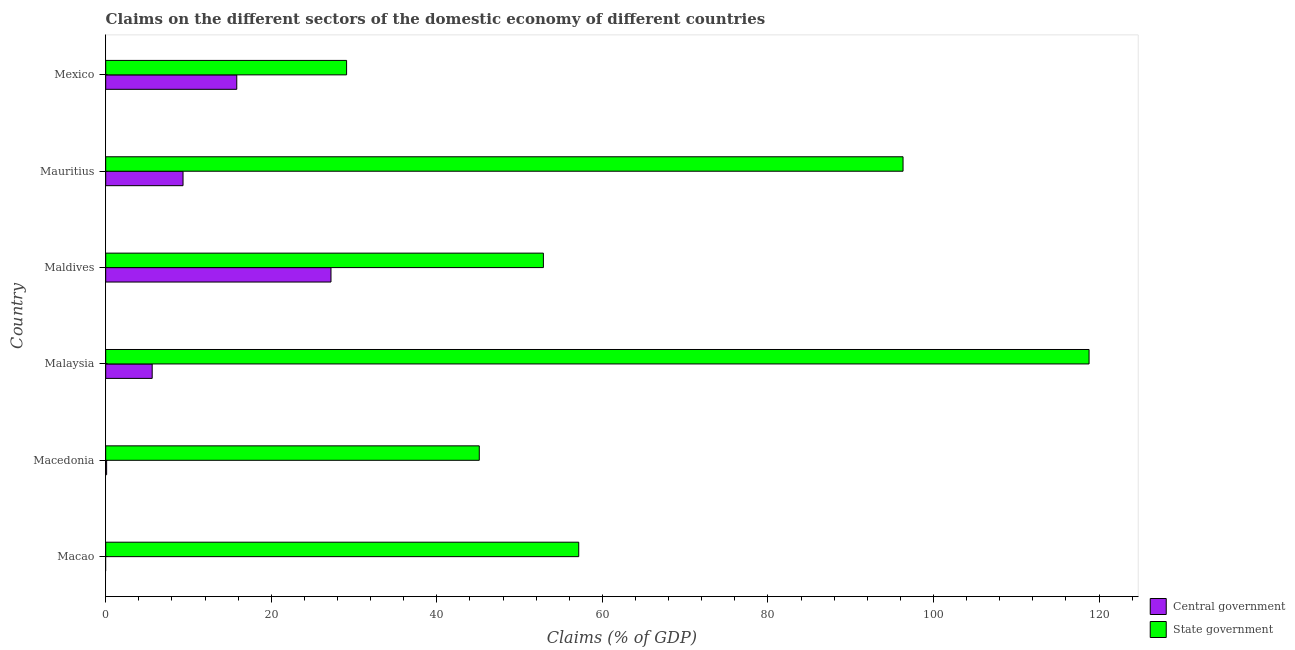How many different coloured bars are there?
Provide a succinct answer. 2. How many bars are there on the 3rd tick from the top?
Give a very brief answer. 2. In how many cases, is the number of bars for a given country not equal to the number of legend labels?
Offer a terse response. 1. What is the claims on state government in Mauritius?
Your response must be concise. 96.32. Across all countries, what is the maximum claims on central government?
Make the answer very short. 27.22. Across all countries, what is the minimum claims on state government?
Provide a succinct answer. 29.1. In which country was the claims on state government maximum?
Your response must be concise. Malaysia. What is the total claims on central government in the graph?
Your answer should be compact. 58.12. What is the difference between the claims on central government in Mauritius and that in Mexico?
Offer a very short reply. -6.49. What is the difference between the claims on central government in Mauritius and the claims on state government in Macedonia?
Your response must be concise. -35.79. What is the average claims on state government per country?
Offer a very short reply. 66.56. What is the difference between the claims on state government and claims on central government in Mauritius?
Keep it short and to the point. 86.98. In how many countries, is the claims on state government greater than 92 %?
Provide a succinct answer. 2. What is the ratio of the claims on state government in Macao to that in Mexico?
Your answer should be compact. 1.96. What is the difference between the highest and the second highest claims on state government?
Provide a short and direct response. 22.47. What is the difference between the highest and the lowest claims on state government?
Your answer should be compact. 89.69. Is the sum of the claims on state government in Macedonia and Mexico greater than the maximum claims on central government across all countries?
Your answer should be very brief. Yes. How many bars are there?
Keep it short and to the point. 11. How many countries are there in the graph?
Offer a very short reply. 6. What is the difference between two consecutive major ticks on the X-axis?
Your response must be concise. 20. Does the graph contain any zero values?
Give a very brief answer. Yes. Does the graph contain grids?
Offer a terse response. No. How many legend labels are there?
Offer a very short reply. 2. How are the legend labels stacked?
Your answer should be compact. Vertical. What is the title of the graph?
Offer a terse response. Claims on the different sectors of the domestic economy of different countries. What is the label or title of the X-axis?
Provide a short and direct response. Claims (% of GDP). What is the label or title of the Y-axis?
Provide a succinct answer. Country. What is the Claims (% of GDP) in State government in Macao?
Keep it short and to the point. 57.14. What is the Claims (% of GDP) in Central government in Macedonia?
Your response must be concise. 0.11. What is the Claims (% of GDP) of State government in Macedonia?
Offer a terse response. 45.13. What is the Claims (% of GDP) in Central government in Malaysia?
Keep it short and to the point. 5.62. What is the Claims (% of GDP) of State government in Malaysia?
Offer a terse response. 118.79. What is the Claims (% of GDP) in Central government in Maldives?
Provide a succinct answer. 27.22. What is the Claims (% of GDP) of State government in Maldives?
Offer a terse response. 52.87. What is the Claims (% of GDP) in Central government in Mauritius?
Your response must be concise. 9.34. What is the Claims (% of GDP) of State government in Mauritius?
Your answer should be very brief. 96.32. What is the Claims (% of GDP) of Central government in Mexico?
Give a very brief answer. 15.83. What is the Claims (% of GDP) of State government in Mexico?
Provide a succinct answer. 29.1. Across all countries, what is the maximum Claims (% of GDP) of Central government?
Make the answer very short. 27.22. Across all countries, what is the maximum Claims (% of GDP) in State government?
Offer a terse response. 118.79. Across all countries, what is the minimum Claims (% of GDP) of Central government?
Offer a very short reply. 0. Across all countries, what is the minimum Claims (% of GDP) in State government?
Make the answer very short. 29.1. What is the total Claims (% of GDP) of Central government in the graph?
Ensure brevity in your answer.  58.12. What is the total Claims (% of GDP) in State government in the graph?
Ensure brevity in your answer.  399.36. What is the difference between the Claims (% of GDP) in State government in Macao and that in Macedonia?
Your response must be concise. 12.01. What is the difference between the Claims (% of GDP) in State government in Macao and that in Malaysia?
Make the answer very short. -61.65. What is the difference between the Claims (% of GDP) in State government in Macao and that in Maldives?
Keep it short and to the point. 4.27. What is the difference between the Claims (% of GDP) in State government in Macao and that in Mauritius?
Your response must be concise. -39.18. What is the difference between the Claims (% of GDP) of State government in Macao and that in Mexico?
Your answer should be compact. 28.04. What is the difference between the Claims (% of GDP) in Central government in Macedonia and that in Malaysia?
Give a very brief answer. -5.5. What is the difference between the Claims (% of GDP) in State government in Macedonia and that in Malaysia?
Make the answer very short. -73.66. What is the difference between the Claims (% of GDP) of Central government in Macedonia and that in Maldives?
Ensure brevity in your answer.  -27.1. What is the difference between the Claims (% of GDP) of State government in Macedonia and that in Maldives?
Keep it short and to the point. -7.74. What is the difference between the Claims (% of GDP) of Central government in Macedonia and that in Mauritius?
Your answer should be compact. -9.23. What is the difference between the Claims (% of GDP) in State government in Macedonia and that in Mauritius?
Your answer should be very brief. -51.19. What is the difference between the Claims (% of GDP) of Central government in Macedonia and that in Mexico?
Your answer should be very brief. -15.72. What is the difference between the Claims (% of GDP) in State government in Macedonia and that in Mexico?
Ensure brevity in your answer.  16.03. What is the difference between the Claims (% of GDP) in Central government in Malaysia and that in Maldives?
Keep it short and to the point. -21.6. What is the difference between the Claims (% of GDP) in State government in Malaysia and that in Maldives?
Your answer should be very brief. 65.92. What is the difference between the Claims (% of GDP) of Central government in Malaysia and that in Mauritius?
Your response must be concise. -3.72. What is the difference between the Claims (% of GDP) of State government in Malaysia and that in Mauritius?
Give a very brief answer. 22.47. What is the difference between the Claims (% of GDP) of Central government in Malaysia and that in Mexico?
Provide a succinct answer. -10.22. What is the difference between the Claims (% of GDP) of State government in Malaysia and that in Mexico?
Ensure brevity in your answer.  89.69. What is the difference between the Claims (% of GDP) of Central government in Maldives and that in Mauritius?
Your answer should be compact. 17.87. What is the difference between the Claims (% of GDP) of State government in Maldives and that in Mauritius?
Your answer should be compact. -43.45. What is the difference between the Claims (% of GDP) in Central government in Maldives and that in Mexico?
Keep it short and to the point. 11.38. What is the difference between the Claims (% of GDP) in State government in Maldives and that in Mexico?
Make the answer very short. 23.77. What is the difference between the Claims (% of GDP) of Central government in Mauritius and that in Mexico?
Provide a succinct answer. -6.49. What is the difference between the Claims (% of GDP) in State government in Mauritius and that in Mexico?
Offer a very short reply. 67.22. What is the difference between the Claims (% of GDP) in Central government in Macedonia and the Claims (% of GDP) in State government in Malaysia?
Your answer should be very brief. -118.68. What is the difference between the Claims (% of GDP) of Central government in Macedonia and the Claims (% of GDP) of State government in Maldives?
Give a very brief answer. -52.76. What is the difference between the Claims (% of GDP) of Central government in Macedonia and the Claims (% of GDP) of State government in Mauritius?
Your response must be concise. -96.21. What is the difference between the Claims (% of GDP) of Central government in Macedonia and the Claims (% of GDP) of State government in Mexico?
Give a very brief answer. -28.99. What is the difference between the Claims (% of GDP) in Central government in Malaysia and the Claims (% of GDP) in State government in Maldives?
Your answer should be compact. -47.26. What is the difference between the Claims (% of GDP) in Central government in Malaysia and the Claims (% of GDP) in State government in Mauritius?
Offer a very short reply. -90.7. What is the difference between the Claims (% of GDP) in Central government in Malaysia and the Claims (% of GDP) in State government in Mexico?
Give a very brief answer. -23.48. What is the difference between the Claims (% of GDP) of Central government in Maldives and the Claims (% of GDP) of State government in Mauritius?
Ensure brevity in your answer.  -69.11. What is the difference between the Claims (% of GDP) of Central government in Maldives and the Claims (% of GDP) of State government in Mexico?
Keep it short and to the point. -1.89. What is the difference between the Claims (% of GDP) in Central government in Mauritius and the Claims (% of GDP) in State government in Mexico?
Keep it short and to the point. -19.76. What is the average Claims (% of GDP) in Central government per country?
Offer a very short reply. 9.69. What is the average Claims (% of GDP) in State government per country?
Provide a succinct answer. 66.56. What is the difference between the Claims (% of GDP) in Central government and Claims (% of GDP) in State government in Macedonia?
Your response must be concise. -45.02. What is the difference between the Claims (% of GDP) of Central government and Claims (% of GDP) of State government in Malaysia?
Your answer should be compact. -113.18. What is the difference between the Claims (% of GDP) of Central government and Claims (% of GDP) of State government in Maldives?
Provide a short and direct response. -25.66. What is the difference between the Claims (% of GDP) in Central government and Claims (% of GDP) in State government in Mauritius?
Provide a succinct answer. -86.98. What is the difference between the Claims (% of GDP) in Central government and Claims (% of GDP) in State government in Mexico?
Provide a short and direct response. -13.27. What is the ratio of the Claims (% of GDP) in State government in Macao to that in Macedonia?
Your answer should be very brief. 1.27. What is the ratio of the Claims (% of GDP) in State government in Macao to that in Malaysia?
Your answer should be very brief. 0.48. What is the ratio of the Claims (% of GDP) in State government in Macao to that in Maldives?
Provide a succinct answer. 1.08. What is the ratio of the Claims (% of GDP) in State government in Macao to that in Mauritius?
Your answer should be very brief. 0.59. What is the ratio of the Claims (% of GDP) in State government in Macao to that in Mexico?
Ensure brevity in your answer.  1.96. What is the ratio of the Claims (% of GDP) of Central government in Macedonia to that in Malaysia?
Your response must be concise. 0.02. What is the ratio of the Claims (% of GDP) of State government in Macedonia to that in Malaysia?
Your response must be concise. 0.38. What is the ratio of the Claims (% of GDP) in Central government in Macedonia to that in Maldives?
Your answer should be very brief. 0. What is the ratio of the Claims (% of GDP) in State government in Macedonia to that in Maldives?
Your answer should be compact. 0.85. What is the ratio of the Claims (% of GDP) of Central government in Macedonia to that in Mauritius?
Keep it short and to the point. 0.01. What is the ratio of the Claims (% of GDP) in State government in Macedonia to that in Mauritius?
Your response must be concise. 0.47. What is the ratio of the Claims (% of GDP) in Central government in Macedonia to that in Mexico?
Provide a short and direct response. 0.01. What is the ratio of the Claims (% of GDP) of State government in Macedonia to that in Mexico?
Your response must be concise. 1.55. What is the ratio of the Claims (% of GDP) in Central government in Malaysia to that in Maldives?
Offer a terse response. 0.21. What is the ratio of the Claims (% of GDP) of State government in Malaysia to that in Maldives?
Offer a terse response. 2.25. What is the ratio of the Claims (% of GDP) in Central government in Malaysia to that in Mauritius?
Your response must be concise. 0.6. What is the ratio of the Claims (% of GDP) of State government in Malaysia to that in Mauritius?
Ensure brevity in your answer.  1.23. What is the ratio of the Claims (% of GDP) of Central government in Malaysia to that in Mexico?
Keep it short and to the point. 0.35. What is the ratio of the Claims (% of GDP) in State government in Malaysia to that in Mexico?
Offer a terse response. 4.08. What is the ratio of the Claims (% of GDP) in Central government in Maldives to that in Mauritius?
Make the answer very short. 2.91. What is the ratio of the Claims (% of GDP) in State government in Maldives to that in Mauritius?
Your response must be concise. 0.55. What is the ratio of the Claims (% of GDP) in Central government in Maldives to that in Mexico?
Offer a terse response. 1.72. What is the ratio of the Claims (% of GDP) in State government in Maldives to that in Mexico?
Provide a short and direct response. 1.82. What is the ratio of the Claims (% of GDP) of Central government in Mauritius to that in Mexico?
Ensure brevity in your answer.  0.59. What is the ratio of the Claims (% of GDP) in State government in Mauritius to that in Mexico?
Your response must be concise. 3.31. What is the difference between the highest and the second highest Claims (% of GDP) of Central government?
Give a very brief answer. 11.38. What is the difference between the highest and the second highest Claims (% of GDP) of State government?
Offer a terse response. 22.47. What is the difference between the highest and the lowest Claims (% of GDP) in Central government?
Offer a terse response. 27.22. What is the difference between the highest and the lowest Claims (% of GDP) in State government?
Your answer should be compact. 89.69. 